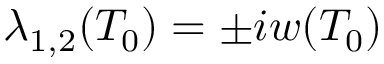<formula> <loc_0><loc_0><loc_500><loc_500>\lambda _ { 1 , 2 } ( T _ { 0 } ) = \pm i w ( T _ { 0 } )</formula> 